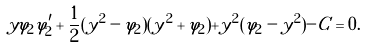Convert formula to latex. <formula><loc_0><loc_0><loc_500><loc_500>y \varphi _ { 2 } \varphi _ { 2 } ^ { \prime } + \frac { 1 } { 2 } ( y ^ { 2 } - \varphi _ { 2 } ) ( y ^ { 2 } + \varphi _ { 2 } ) + y ^ { 2 } ( \varphi _ { 2 } - y ^ { 2 } ) - C = 0 .</formula> 